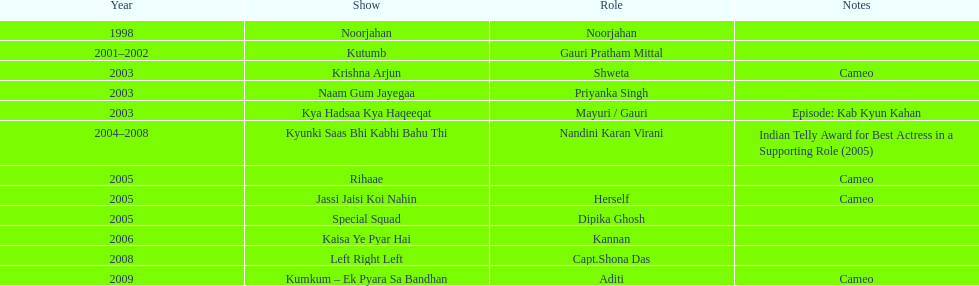What was the first tv series that gauri tejwani appeared in? Noorjahan. 